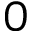<formula> <loc_0><loc_0><loc_500><loc_500>0</formula> 